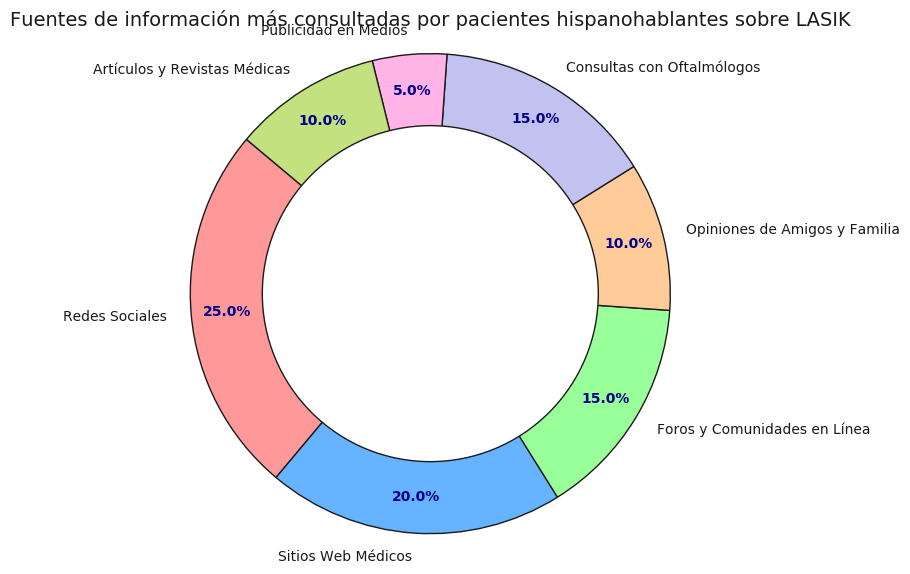¿Qué fuente de información es la más consultada por pacientes hispanohablantes sobre LASIK? Observamos que el sector más grande del gráfico corresponde a "Redes Sociales". Este segmento ocupa el 25%, lo que indica que es la fuente más consultada.
Answer: Redes Sociales ¿Qué porcentaje total suman las consultas con oftalmólogos y las comunidades en línea? Sumamos los porcentajes de "Consultas con Oftalmólogos" (15%) y "Foros y Comunidades en Línea" (15%). La suma es 15% + 15% = 30%.
Answer: 30% ¿Cuál es la fuente de información menos consultada? Observamos el sector más pequeño del gráfico que es "Publicidad en Medios" con un 5%.
Answer: Publicidad en Medios ¿Cuántos sectores tienen un porcentaje superior al 15%? Contamos los sectores con porcentajes superiores al 15%: "Redes Sociales" (25%) y "Sitios Web Médicos" (20%). Hay dos sectores que cumplen con esta condición.
Answer: 2 ¿Las opiniones de amigos y familia tienen un porcentaje mayor o menor que los artículos y revistas médicas? Comparamos los porcentajes de "Opiniones de Amigos y Familia" (10%) y "Artículos y Revistas Médicas" (10%). Ambos tienen el mismo porcentaje.
Answer: Igual ¿Qué porcentaje total suman las fuentes de información personalizadas (consultas y opiniones de amigos y familia)? Sumamos los porcentajes de "Consultas con Oftalmólogos" (15%) y "Opiniones de Amigos y Familia" (10%). La suma es 15% + 10% = 25%.
Answer: 25% ¿Cuál es la diferencia de porcentaje entre consultas con oftalmólogos y redes sociales? Restamos el porcentaje de "Consultas con Oftalmólogos" (15%) del porcentaje de "Redes Sociales" (25%). La diferencia es 25% - 15% = 10%.
Answer: 10% ¿Qué fuentes de información tienen el mismo porcentaje? Observamos que "Foros y Comunidades en Línea" y "Consultas con Oftalmólogos" ambos tienen un 15%, y "Opiniones de Amigos y Familia" y "Artículos y Revistas Médicas" ambos tienen un 10%.
Answer: Foros y Comunidades en Línea - Consultas con Oftalmólogos, Opiniones de Amigos y Familia - Artículos y Revistas Médicas Considerando solo las fuentes de información en línea, ¿qué porcentaje total suma? Sumamos los porcentajes de "Redes Sociales" (25%), "Sitios Web Médicos" (20%), y "Foros y Comunidades en Línea" (15%). La suma es 25% + 20% + 15% = 60%.
Answer: 60% 